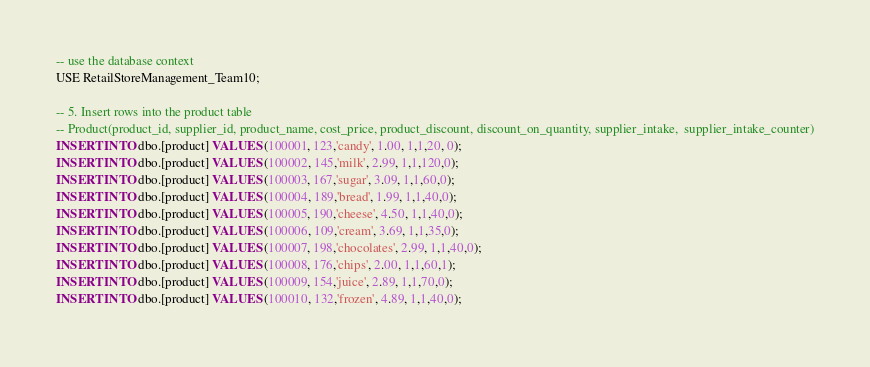Convert code to text. <code><loc_0><loc_0><loc_500><loc_500><_SQL_>-- use the database context
USE RetailStoreManagement_Team10;

-- 5. Insert rows into the product table
-- Product(product_id, supplier_id, product_name, cost_price, product_discount, discount_on_quantity, supplier_intake,  supplier_intake_counter)
INSERT INTO dbo.[product] VALUES (100001, 123,'candy', 1.00, 1,1,20, 0);
INSERT INTO dbo.[product] VALUES (100002, 145,'milk', 2.99, 1,1,120,0);
INSERT INTO dbo.[product] VALUES (100003, 167,'sugar', 3.09, 1,1,60,0);
INSERT INTO dbo.[product] VALUES (100004, 189,'bread', 1.99, 1,1,40,0);
INSERT INTO dbo.[product] VALUES (100005, 190,'cheese', 4.50, 1,1,40,0);
INSERT INTO dbo.[product] VALUES (100006, 109,'cream', 3.69, 1,1,35,0);
INSERT INTO dbo.[product] VALUES (100007, 198,'chocolates', 2.99, 1,1,40,0);
INSERT INTO dbo.[product] VALUES (100008, 176,'chips', 2.00, 1,1,60,1);
INSERT INTO dbo.[product] VALUES (100009, 154,'juice', 2.89, 1,1,70,0);
INSERT INTO dbo.[product] VALUES (100010, 132,'frozen', 4.89, 1,1,40,0);</code> 